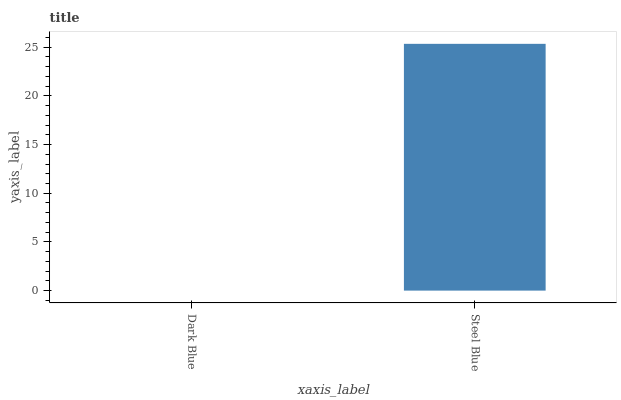Is Dark Blue the minimum?
Answer yes or no. Yes. Is Steel Blue the maximum?
Answer yes or no. Yes. Is Steel Blue the minimum?
Answer yes or no. No. Is Steel Blue greater than Dark Blue?
Answer yes or no. Yes. Is Dark Blue less than Steel Blue?
Answer yes or no. Yes. Is Dark Blue greater than Steel Blue?
Answer yes or no. No. Is Steel Blue less than Dark Blue?
Answer yes or no. No. Is Steel Blue the high median?
Answer yes or no. Yes. Is Dark Blue the low median?
Answer yes or no. Yes. Is Dark Blue the high median?
Answer yes or no. No. Is Steel Blue the low median?
Answer yes or no. No. 